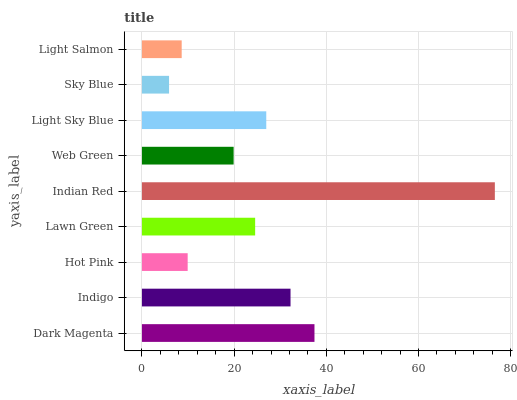Is Sky Blue the minimum?
Answer yes or no. Yes. Is Indian Red the maximum?
Answer yes or no. Yes. Is Indigo the minimum?
Answer yes or no. No. Is Indigo the maximum?
Answer yes or no. No. Is Dark Magenta greater than Indigo?
Answer yes or no. Yes. Is Indigo less than Dark Magenta?
Answer yes or no. Yes. Is Indigo greater than Dark Magenta?
Answer yes or no. No. Is Dark Magenta less than Indigo?
Answer yes or no. No. Is Lawn Green the high median?
Answer yes or no. Yes. Is Lawn Green the low median?
Answer yes or no. Yes. Is Dark Magenta the high median?
Answer yes or no. No. Is Dark Magenta the low median?
Answer yes or no. No. 